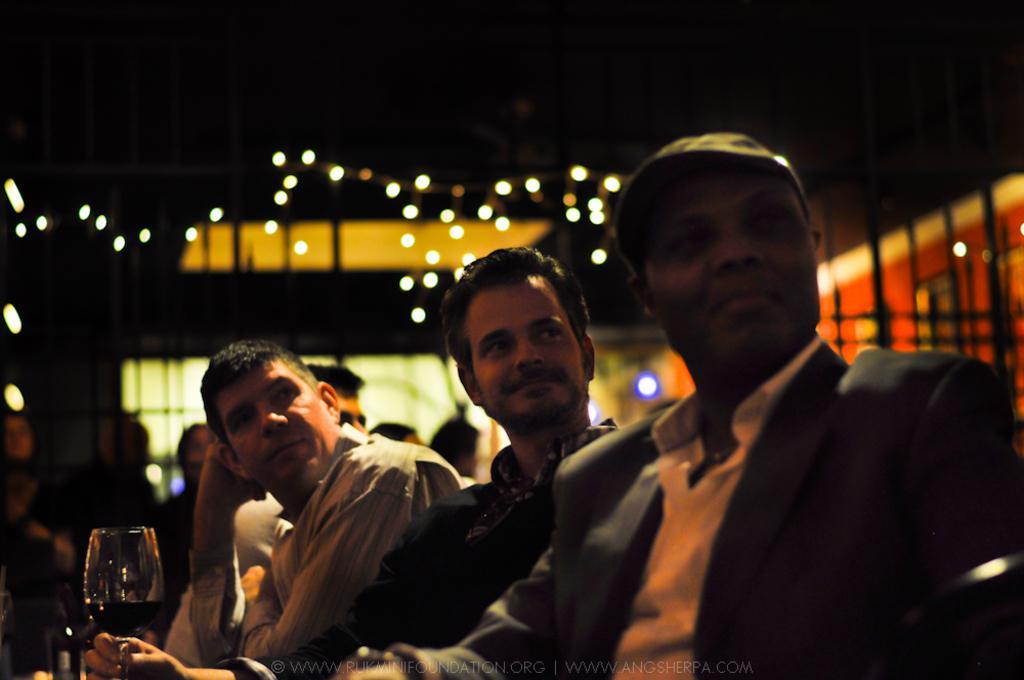Could you give a brief overview of what you see in this image? In this image I can see few persons sitting. There is a glass of wine, there are people in the background , there are lights and there is a blur background. 